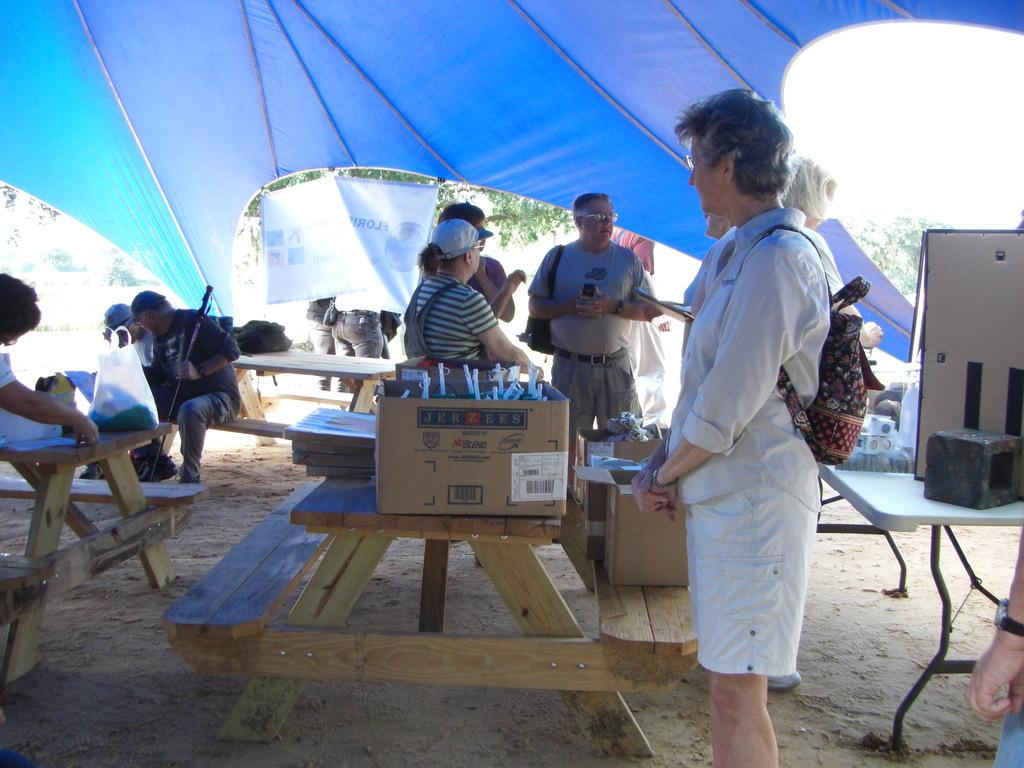What are the people in the image doing? There are people standing and sitting in the image. What furniture is present in the image? There is a table and benches in the image. What is on the table? There are boxes on the table. Where is the setting of the image? The setting is a tent. What can be seen in the background of the image? There is a tree and a banner in the background of the image. What type of pencil can be seen being used by the people in the image? There are no pencils visible in the image; the people are not engaged in any activity that would require a pencil. 